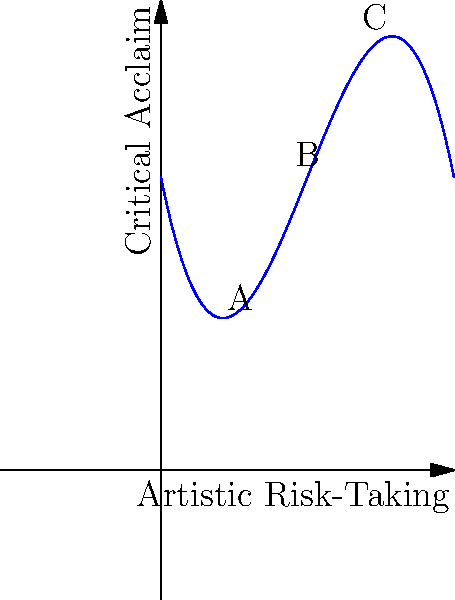The graph represents the relationship between a director's artistic risk-taking (x-axis) and critical acclaim (y-axis). Points A, B, and C represent different directors. Which director should the studio invest in for the highest potential critical acclaim, and what does this imply about the relationship between risk-taking and acclaim in filmmaking? To answer this question, we need to analyze the polynomial graph and its implications:

1. The graph shows a cubic function, representing the complex relationship between artistic risk-taking and critical acclaim.

2. Point A (low risk): Located at the beginning of the curve, representing conservative filmmaking approaches.

3. Point B (moderate risk): Located near the peak of the curve, representing a balance between artistic risk and critical acclaim.

4. Point C (high risk): Located on the descending part of the curve, representing highly experimental approaches.

5. The graph suggests that:
   a) Very low risk-taking (near point A) results in lower critical acclaim.
   b) As risk-taking increases, critical acclaim rises, reaching a peak (near point B).
   c) Beyond the peak, extremely high risk-taking (near point C) leads to diminishing critical acclaim.

6. The studio should invest in the director represented by point B because:
   a) It represents the highest point on the curve, indicating maximum critical acclaim.
   b) It balances artistic risk-taking with audience and critic expectations.

7. This implies that in filmmaking:
   a) Some level of artistic risk-taking is necessary for critical acclaim.
   b) There's an optimal balance between innovation and accessibility.
   c) Extremely avant-garde approaches may alienate critics and audiences, reducing acclaim.
Answer: Invest in director B; optimal balance between risk and acclaim maximizes critical success. 